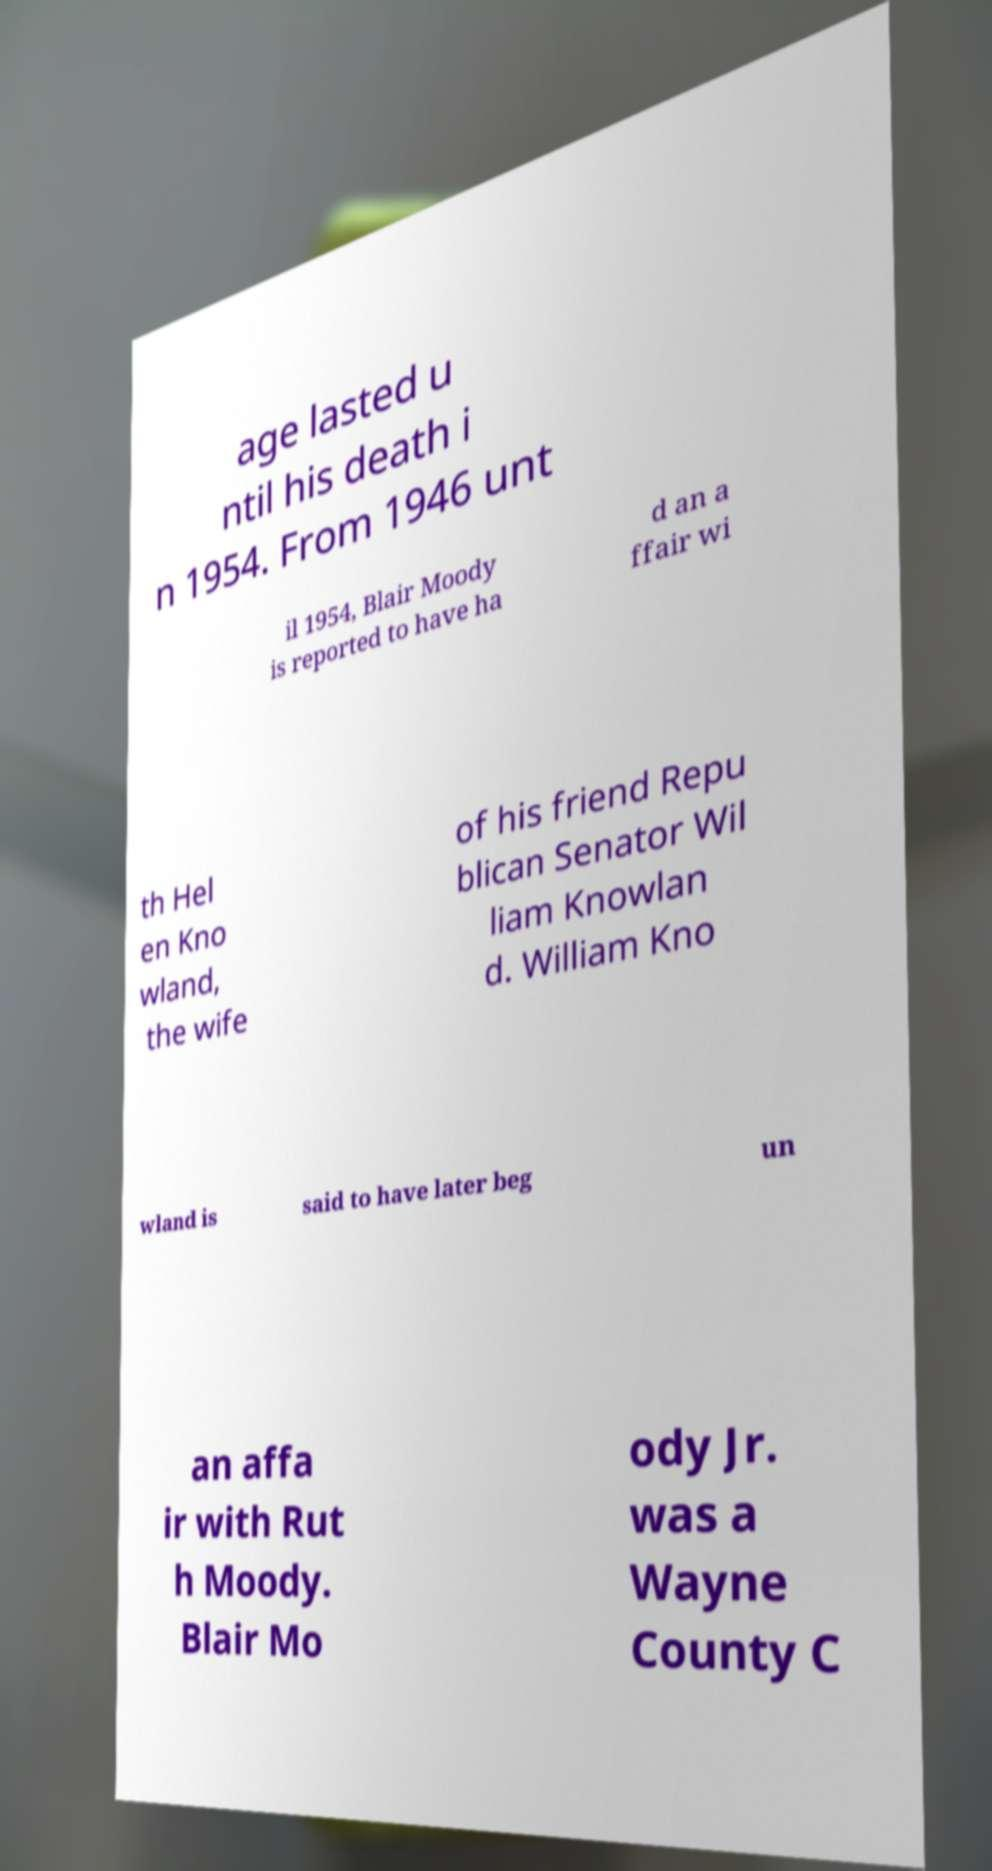For documentation purposes, I need the text within this image transcribed. Could you provide that? age lasted u ntil his death i n 1954. From 1946 unt il 1954, Blair Moody is reported to have ha d an a ffair wi th Hel en Kno wland, the wife of his friend Repu blican Senator Wil liam Knowlan d. William Kno wland is said to have later beg un an affa ir with Rut h Moody. Blair Mo ody Jr. was a Wayne County C 